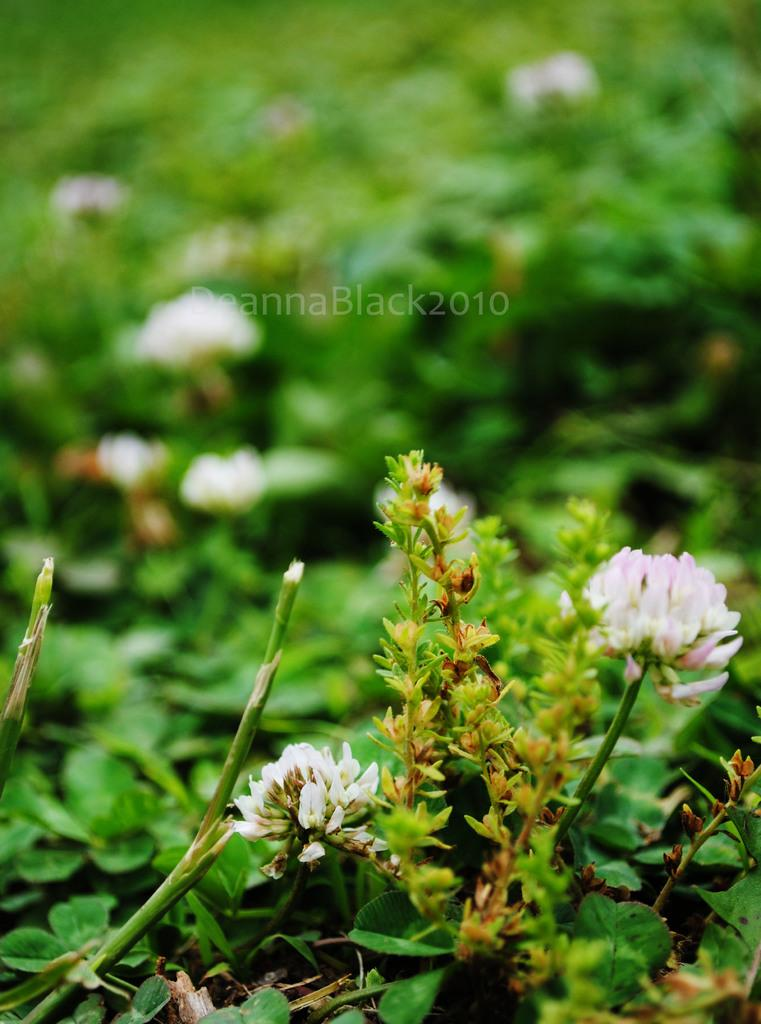What type of plants are in the foreground of the image? There are flower plants in the foreground of the image. What can be seen in the background of the image? There are other plants in the background of the image. How would you describe the appearance of the background in the image? The background of the image is blurry. What type of trucks can be seen driving through the flower plants in the image? There are no trucks present in the image; it features flower plants in the foreground and other plants in the background. 